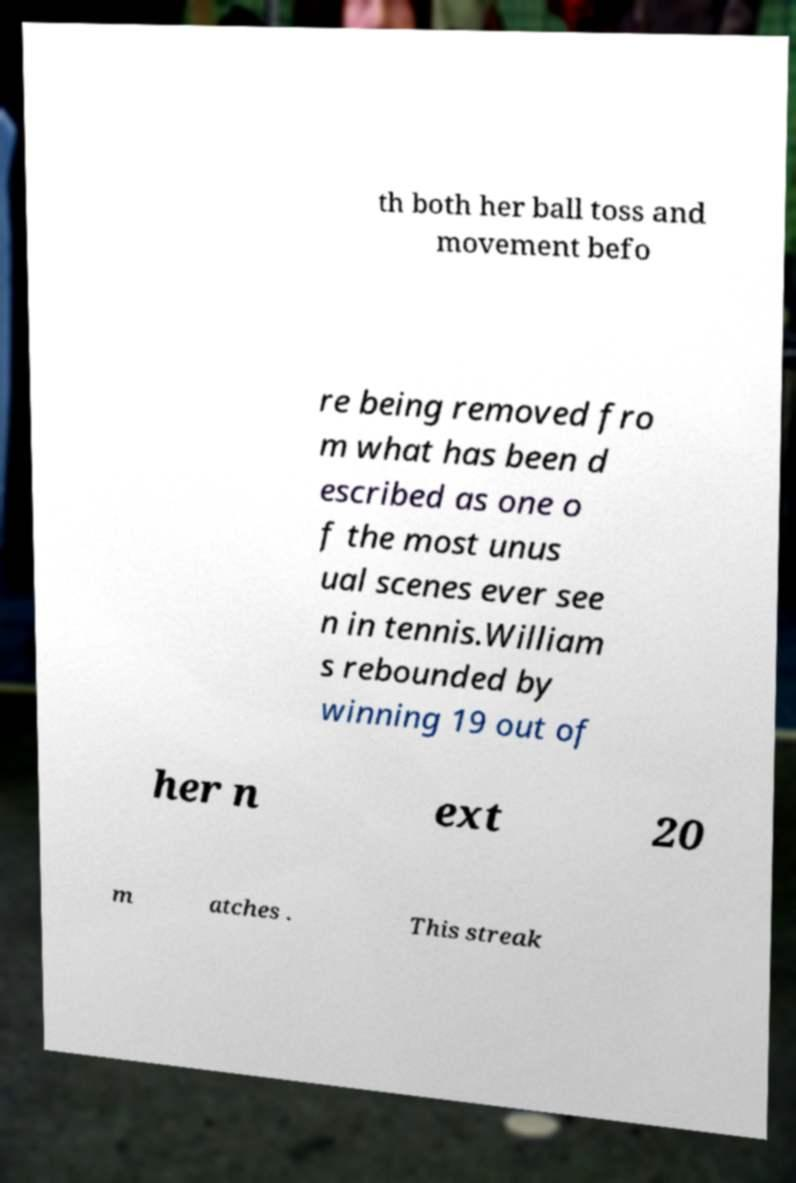Could you extract and type out the text from this image? th both her ball toss and movement befo re being removed fro m what has been d escribed as one o f the most unus ual scenes ever see n in tennis.William s rebounded by winning 19 out of her n ext 20 m atches . This streak 